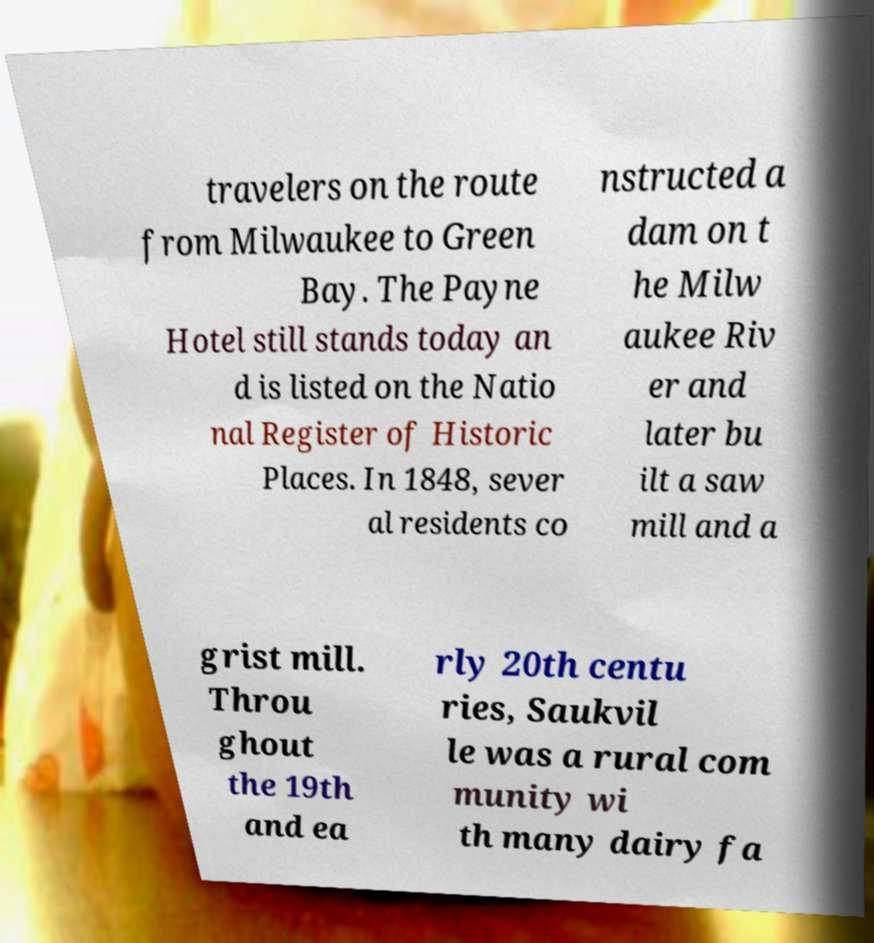For documentation purposes, I need the text within this image transcribed. Could you provide that? travelers on the route from Milwaukee to Green Bay. The Payne Hotel still stands today an d is listed on the Natio nal Register of Historic Places. In 1848, sever al residents co nstructed a dam on t he Milw aukee Riv er and later bu ilt a saw mill and a grist mill. Throu ghout the 19th and ea rly 20th centu ries, Saukvil le was a rural com munity wi th many dairy fa 